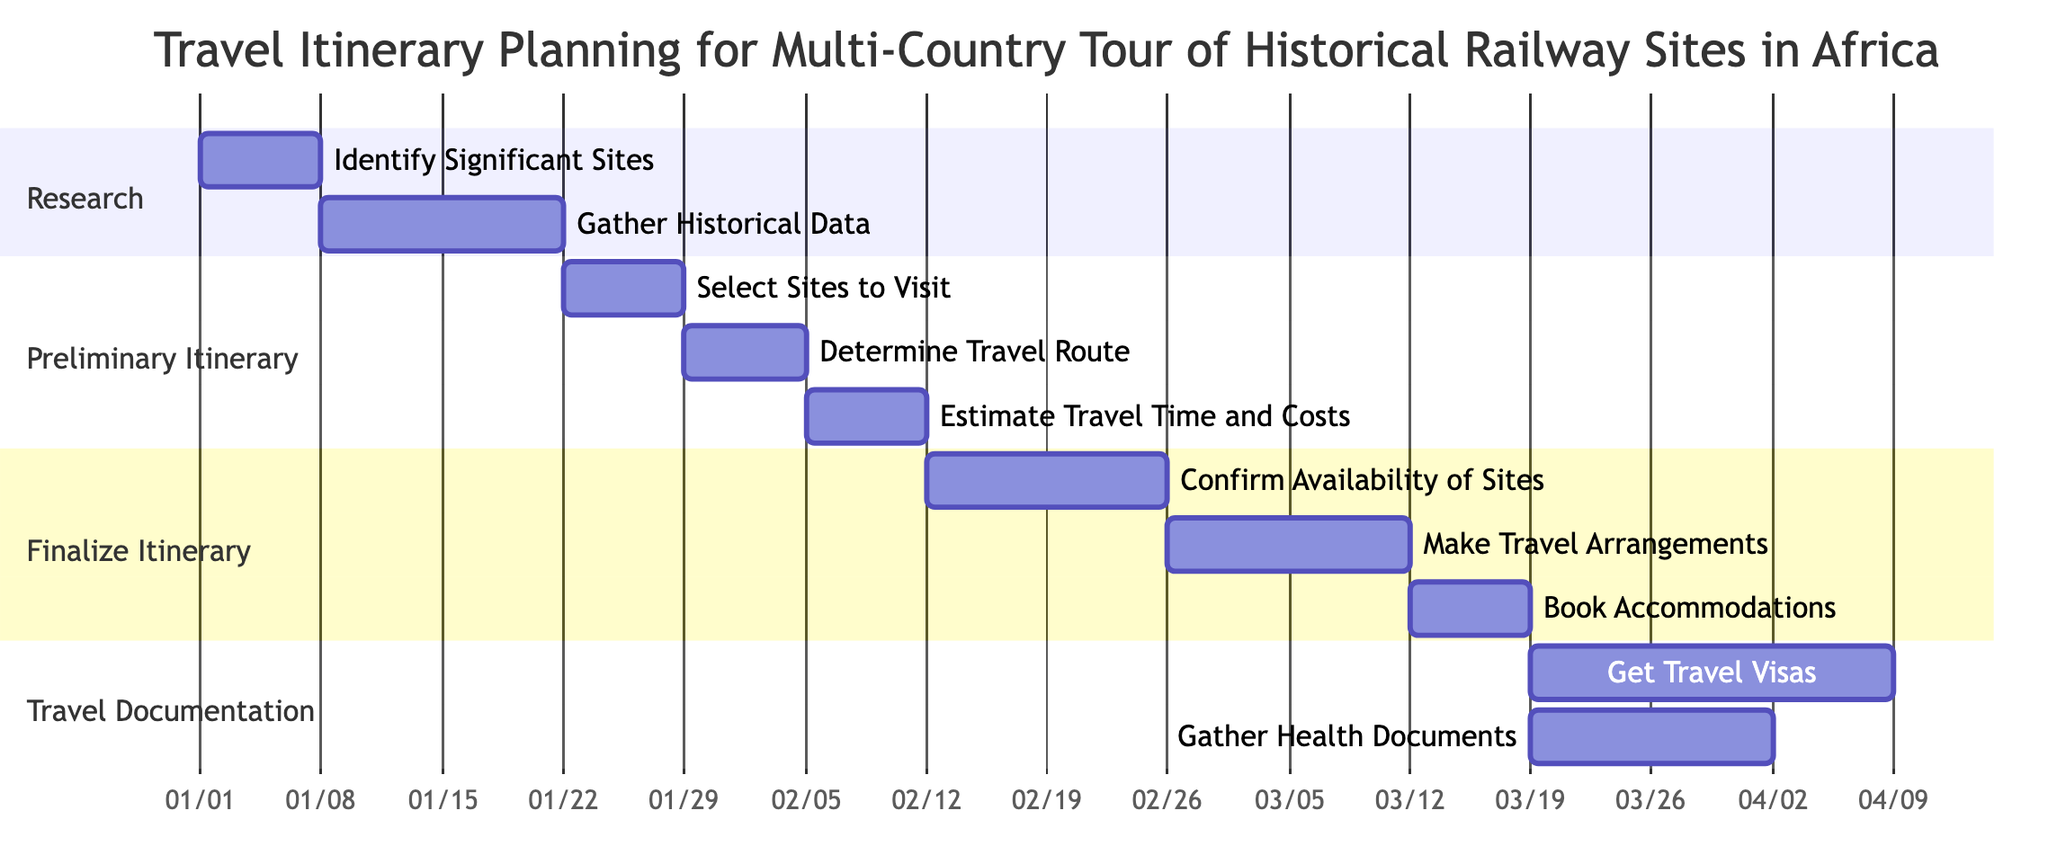What is the total duration for the "Research Historical Railway Sites" task? The task "Research Historical Railway Sites" has a duration specified as "3 Weeks" in the diagram.
Answer: 3 Weeks How many subtasks are under "Create Preliminary Itinerary"? The "Create Preliminary Itinerary" task has three subtasks: "Select Sites to Visit," "Determine Travel Route," and "Estimate Travel Time and Costs." Therefore, there are three subtasks in total.
Answer: 3 What is the dependency for the task "Make Travel Arrangements"? The task "Make Travel Arrangements" depends on the completion of the task "Confirm Availability of Sites," as indicated in the diagram.
Answer: Confirm Availability of Sites What is the duration of the "Get Travel Visas" subtask? The "Get Travel Visas" subtask has a duration of "3 Weeks," which is stated directly in the diagram.
Answer: 3 Weeks Which task must be completed before "Estimate Travel Time and Costs" can begin? "Estimate Travel Time and Costs" cannot begin until "Determine Travel Route" is completed, as this dependency is specified in the diagram.
Answer: Determine Travel Route What is the overall duration for completing the "Finalize Itinerary" section? The "Finalize Itinerary" section consists of tasks with durations of 2 weeks, 2 weeks, and 1 week. Adding these gives a total of 5 weeks for this section.
Answer: 5 Weeks How many weeks total is allocated for preparing travel documentation? The "Prepare Travel Documentation" section has a total duration of "3 Weeks," which includes the combined duration of its subtasks according to the diagram.
Answer: 3 Weeks What is the last task to be completed in the itinerary planning process? The last task in the itinerary planning process, based on the presented diagram, is "Gather Health Documents," as it is the final subtask following "Get Travel Visas."
Answer: Gather Health Documents Which task has the longest duration within the "Finalize Itinerary" section? The longest duration in the "Finalize Itinerary" section is associated with the task "Confirm Availability of Sites," having a duration of "2 Weeks," which is more extended than the others in that section.
Answer: Confirm Availability of Sites 